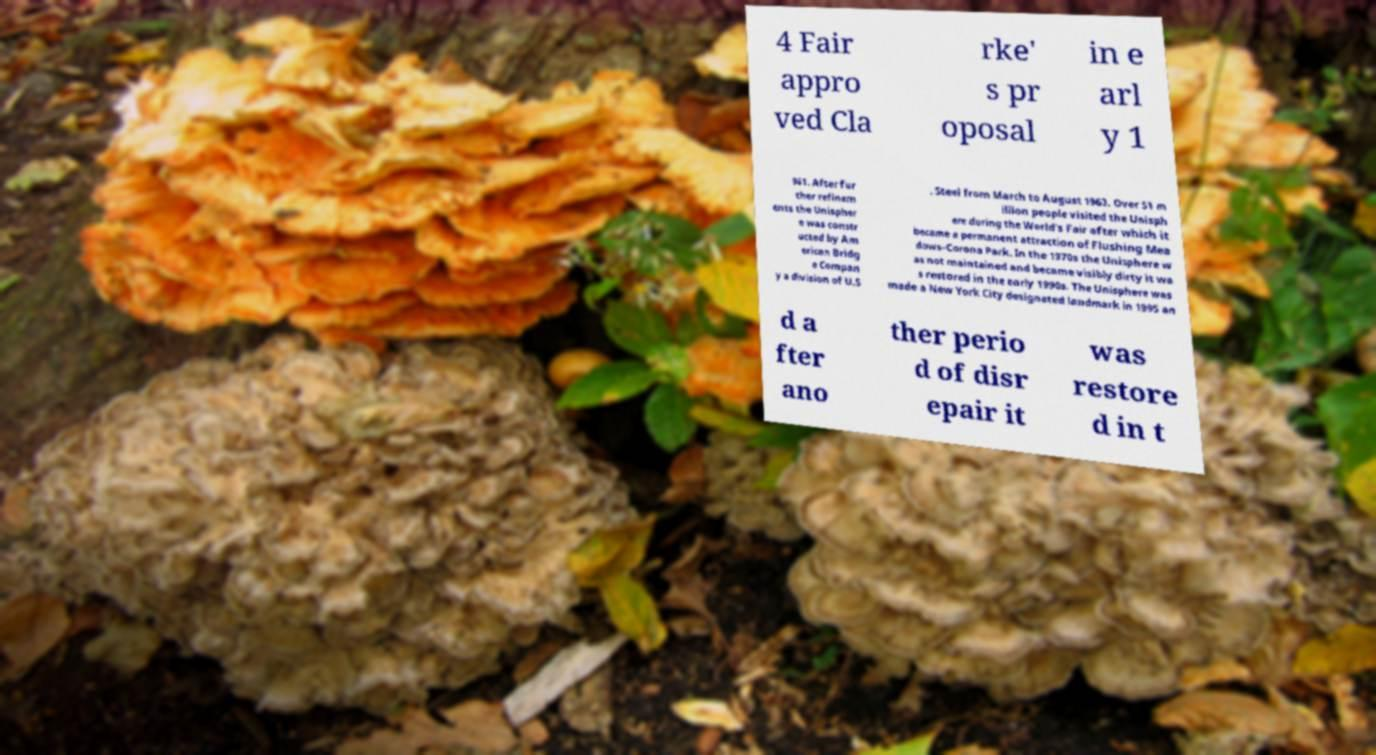Please read and relay the text visible in this image. What does it say? 4 Fair appro ved Cla rke' s pr oposal in e arl y 1 961. After fur ther refinem ents the Unispher e was constr ucted by Am erican Bridg e Compan y a division of U.S . Steel from March to August 1963. Over 51 m illion people visited the Unisph ere during the World's Fair after which it became a permanent attraction of Flushing Mea dows–Corona Park. In the 1970s the Unisphere w as not maintained and became visibly dirty it wa s restored in the early 1990s. The Unisphere was made a New York City designated landmark in 1995 an d a fter ano ther perio d of disr epair it was restore d in t 